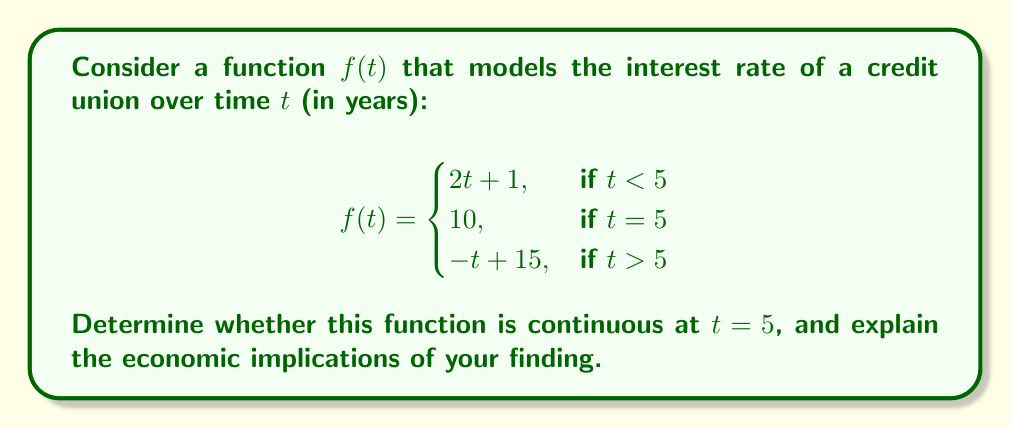Help me with this question. To determine if the function $f(t)$ is continuous at $t = 5$, we need to check three conditions:

1. $f(t)$ is defined at $t = 5$
2. $\lim_{t \to 5^-} f(t)$ exists
3. $\lim_{t \to 5^+} f(t)$ exists
4. $\lim_{t \to 5^-} f(t) = \lim_{t \to 5^+} f(t) = f(5)$

Let's check each condition:

1. $f(5)$ is defined and equals 10.

2. $\lim_{t \to 5^-} f(t) = \lim_{t \to 5^-} (2t + 1) = 2(5) + 1 = 11$

3. $\lim_{t \to 5^+} f(t) = \lim_{t \to 5^+} (-t + 15) = -5 + 15 = 10$

4. $\lim_{t \to 5^-} f(t) = 11 \neq 10 = f(5) = \lim_{t \to 5^+} f(t)$

Since the left-hand limit doesn't equal the function value at $t = 5$, which also doesn't equal the right-hand limit, the function is not continuous at $t = 5$.

Economic Implications:
This discontinuity represents a sudden change in interest rates at the 5-year mark. Such an abrupt change could have significant impacts on credit union operations:

1. It may affect long-term financial planning for both the credit union and its members.
2. It could lead to a sudden shift in borrowing or saving behaviors around the 5-year mark.
3. The discontinuity might represent a policy change or a reaction to external economic factors.
4. It could potentially create arbitrage opportunities or market inefficiencies.

Understanding this discontinuity is crucial for predicting member behavior, managing risk, and developing appropriate financial products.
Answer: The function $f(t)$ is not continuous at $t = 5$ because $\lim_{t \to 5^-} f(t) \neq f(5) \neq \lim_{t \to 5^+} f(t)$. This discontinuity represents an abrupt change in interest rates at the 5-year mark, which has significant implications for credit union operations and member behavior. 